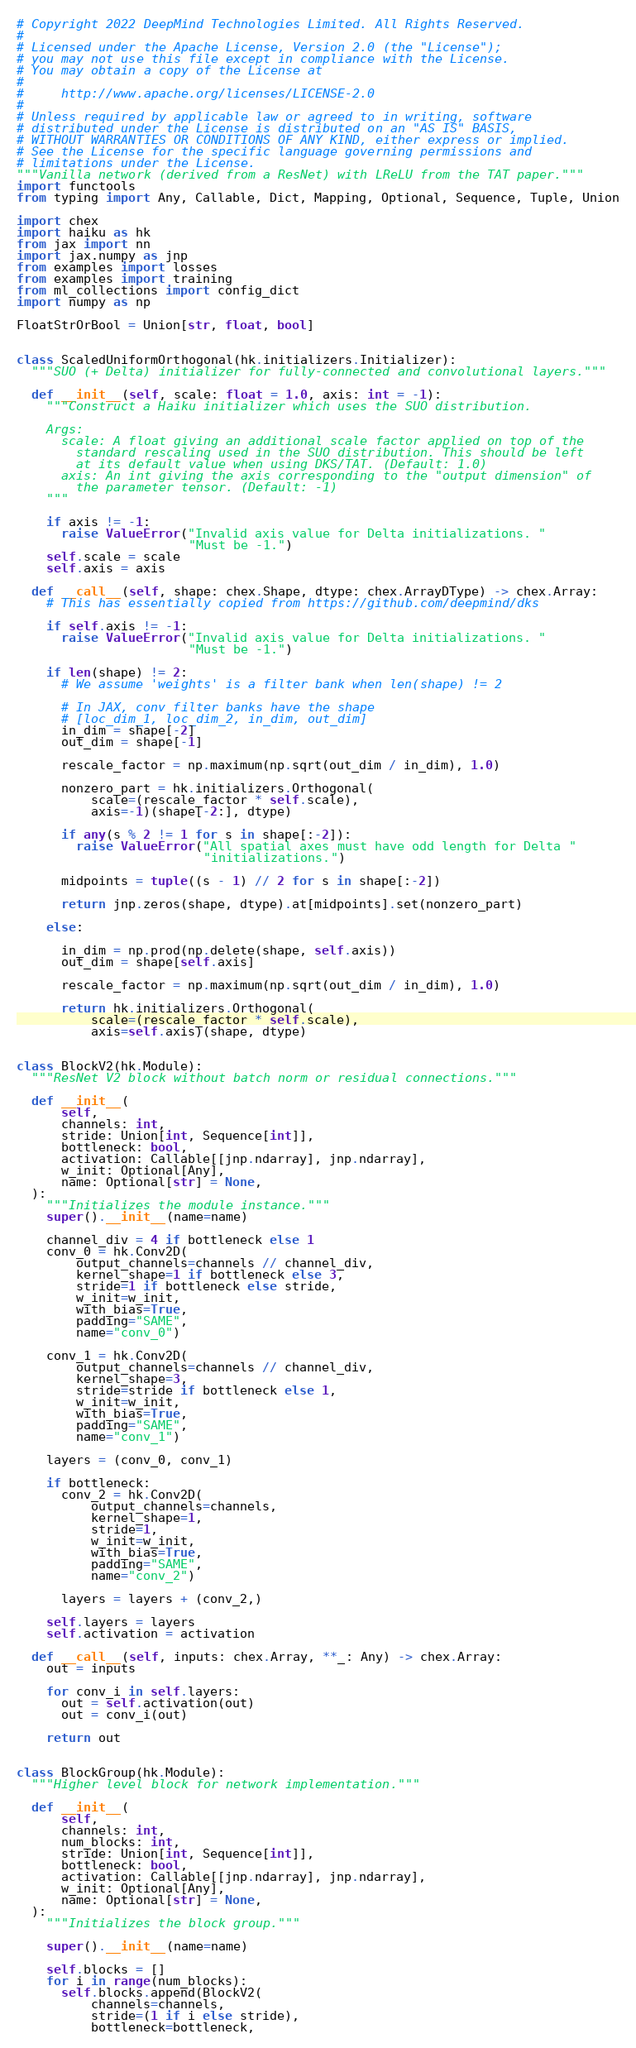Convert code to text. <code><loc_0><loc_0><loc_500><loc_500><_Python_># Copyright 2022 DeepMind Technologies Limited. All Rights Reserved.
#
# Licensed under the Apache License, Version 2.0 (the "License");
# you may not use this file except in compliance with the License.
# You may obtain a copy of the License at
#
#     http://www.apache.org/licenses/LICENSE-2.0
#
# Unless required by applicable law or agreed to in writing, software
# distributed under the License is distributed on an "AS IS" BASIS,
# WITHOUT WARRANTIES OR CONDITIONS OF ANY KIND, either express or implied.
# See the License for the specific language governing permissions and
# limitations under the License.
"""Vanilla network (derived from a ResNet) with LReLU from the TAT paper."""
import functools
from typing import Any, Callable, Dict, Mapping, Optional, Sequence, Tuple, Union

import chex
import haiku as hk
from jax import nn
import jax.numpy as jnp
from examples import losses
from examples import training
from ml_collections import config_dict
import numpy as np

FloatStrOrBool = Union[str, float, bool]


class ScaledUniformOrthogonal(hk.initializers.Initializer):
  """SUO (+ Delta) initializer for fully-connected and convolutional layers."""

  def __init__(self, scale: float = 1.0, axis: int = -1):
    """Construct a Haiku initializer which uses the SUO distribution.

    Args:
      scale: A float giving an additional scale factor applied on top of the
        standard rescaling used in the SUO distribution. This should be left
        at its default value when using DKS/TAT. (Default: 1.0)
      axis: An int giving the axis corresponding to the "output dimension" of
        the parameter tensor. (Default: -1)
    """

    if axis != -1:
      raise ValueError("Invalid axis value for Delta initializations. "
                       "Must be -1.")
    self.scale = scale
    self.axis = axis

  def __call__(self, shape: chex.Shape, dtype: chex.ArrayDType) -> chex.Array:
    # This has essentially copied from https://github.com/deepmind/dks

    if self.axis != -1:
      raise ValueError("Invalid axis value for Delta initializations. "
                       "Must be -1.")

    if len(shape) != 2:
      # We assume 'weights' is a filter bank when len(shape) != 2

      # In JAX, conv filter banks have the shape
      # [loc_dim_1, loc_dim_2, in_dim, out_dim]
      in_dim = shape[-2]
      out_dim = shape[-1]

      rescale_factor = np.maximum(np.sqrt(out_dim / in_dim), 1.0)

      nonzero_part = hk.initializers.Orthogonal(
          scale=(rescale_factor * self.scale),
          axis=-1)(shape[-2:], dtype)

      if any(s % 2 != 1 for s in shape[:-2]):
        raise ValueError("All spatial axes must have odd length for Delta "
                         "initializations.")

      midpoints = tuple((s - 1) // 2 for s in shape[:-2])

      return jnp.zeros(shape, dtype).at[midpoints].set(nonzero_part)

    else:

      in_dim = np.prod(np.delete(shape, self.axis))
      out_dim = shape[self.axis]

      rescale_factor = np.maximum(np.sqrt(out_dim / in_dim), 1.0)

      return hk.initializers.Orthogonal(
          scale=(rescale_factor * self.scale),
          axis=self.axis)(shape, dtype)


class BlockV2(hk.Module):
  """ResNet V2 block without batch norm or residual connections."""

  def __init__(
      self,
      channels: int,
      stride: Union[int, Sequence[int]],
      bottleneck: bool,
      activation: Callable[[jnp.ndarray], jnp.ndarray],
      w_init: Optional[Any],
      name: Optional[str] = None,
  ):
    """Initializes the module instance."""
    super().__init__(name=name)

    channel_div = 4 if bottleneck else 1
    conv_0 = hk.Conv2D(
        output_channels=channels // channel_div,
        kernel_shape=1 if bottleneck else 3,
        stride=1 if bottleneck else stride,
        w_init=w_init,
        with_bias=True,
        padding="SAME",
        name="conv_0")

    conv_1 = hk.Conv2D(
        output_channels=channels // channel_div,
        kernel_shape=3,
        stride=stride if bottleneck else 1,
        w_init=w_init,
        with_bias=True,
        padding="SAME",
        name="conv_1")

    layers = (conv_0, conv_1)

    if bottleneck:
      conv_2 = hk.Conv2D(
          output_channels=channels,
          kernel_shape=1,
          stride=1,
          w_init=w_init,
          with_bias=True,
          padding="SAME",
          name="conv_2")

      layers = layers + (conv_2,)

    self.layers = layers
    self.activation = activation

  def __call__(self, inputs: chex.Array, **_: Any) -> chex.Array:
    out = inputs

    for conv_i in self.layers:
      out = self.activation(out)
      out = conv_i(out)

    return out


class BlockGroup(hk.Module):
  """Higher level block for network implementation."""

  def __init__(
      self,
      channels: int,
      num_blocks: int,
      stride: Union[int, Sequence[int]],
      bottleneck: bool,
      activation: Callable[[jnp.ndarray], jnp.ndarray],
      w_init: Optional[Any],
      name: Optional[str] = None,
  ):
    """Initializes the block group."""

    super().__init__(name=name)

    self.blocks = []
    for i in range(num_blocks):
      self.blocks.append(BlockV2(
          channels=channels,
          stride=(1 if i else stride),
          bottleneck=bottleneck,</code> 